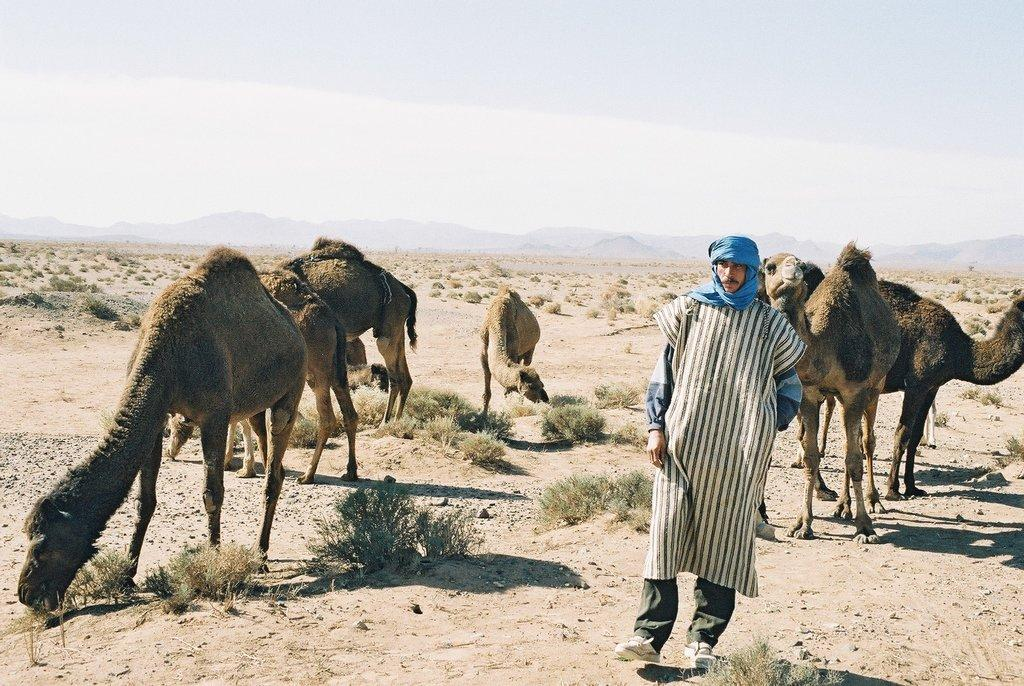What animals can be seen in the image? There are camels in the image. What type of vegetation is present in the image? There are small bushes in the image. Who or what is visible in the foreground? There are persons visible in the foreground. What might be present in the middle of the image? There may be hills in the middle of the image. What is visible at the top of the image? The sky is visible at the top of the image. What language is being spoken by the camels in the image? Camels do not speak any human language, so it is not possible to determine what language they might be speaking in the image. 